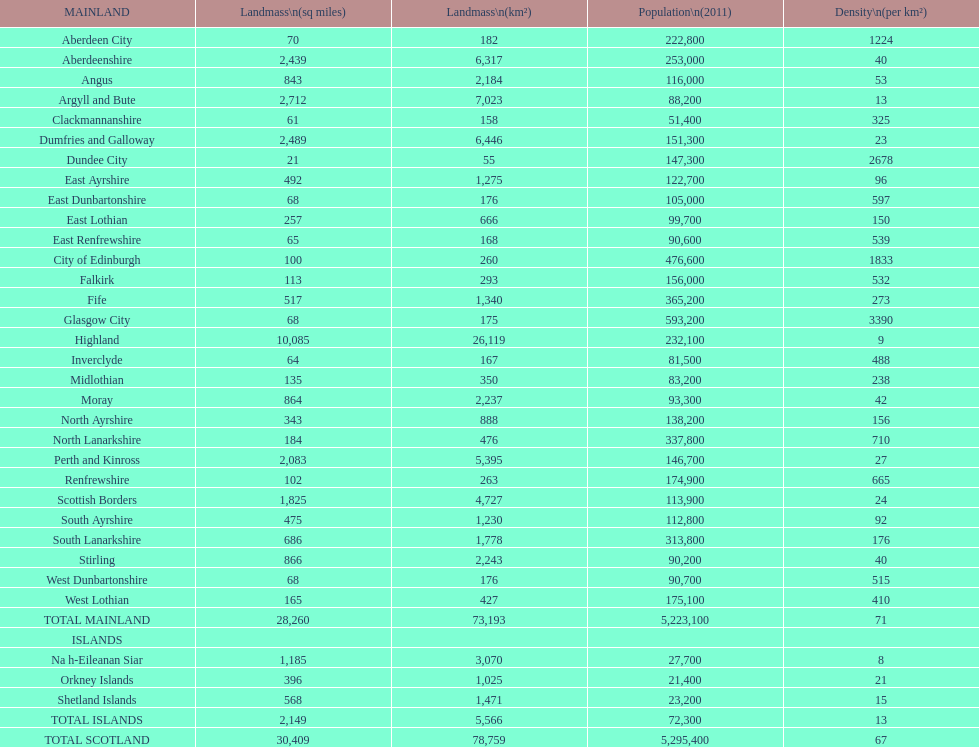Which is the only subdivision to have a greater area than argyll and bute? Highland. 